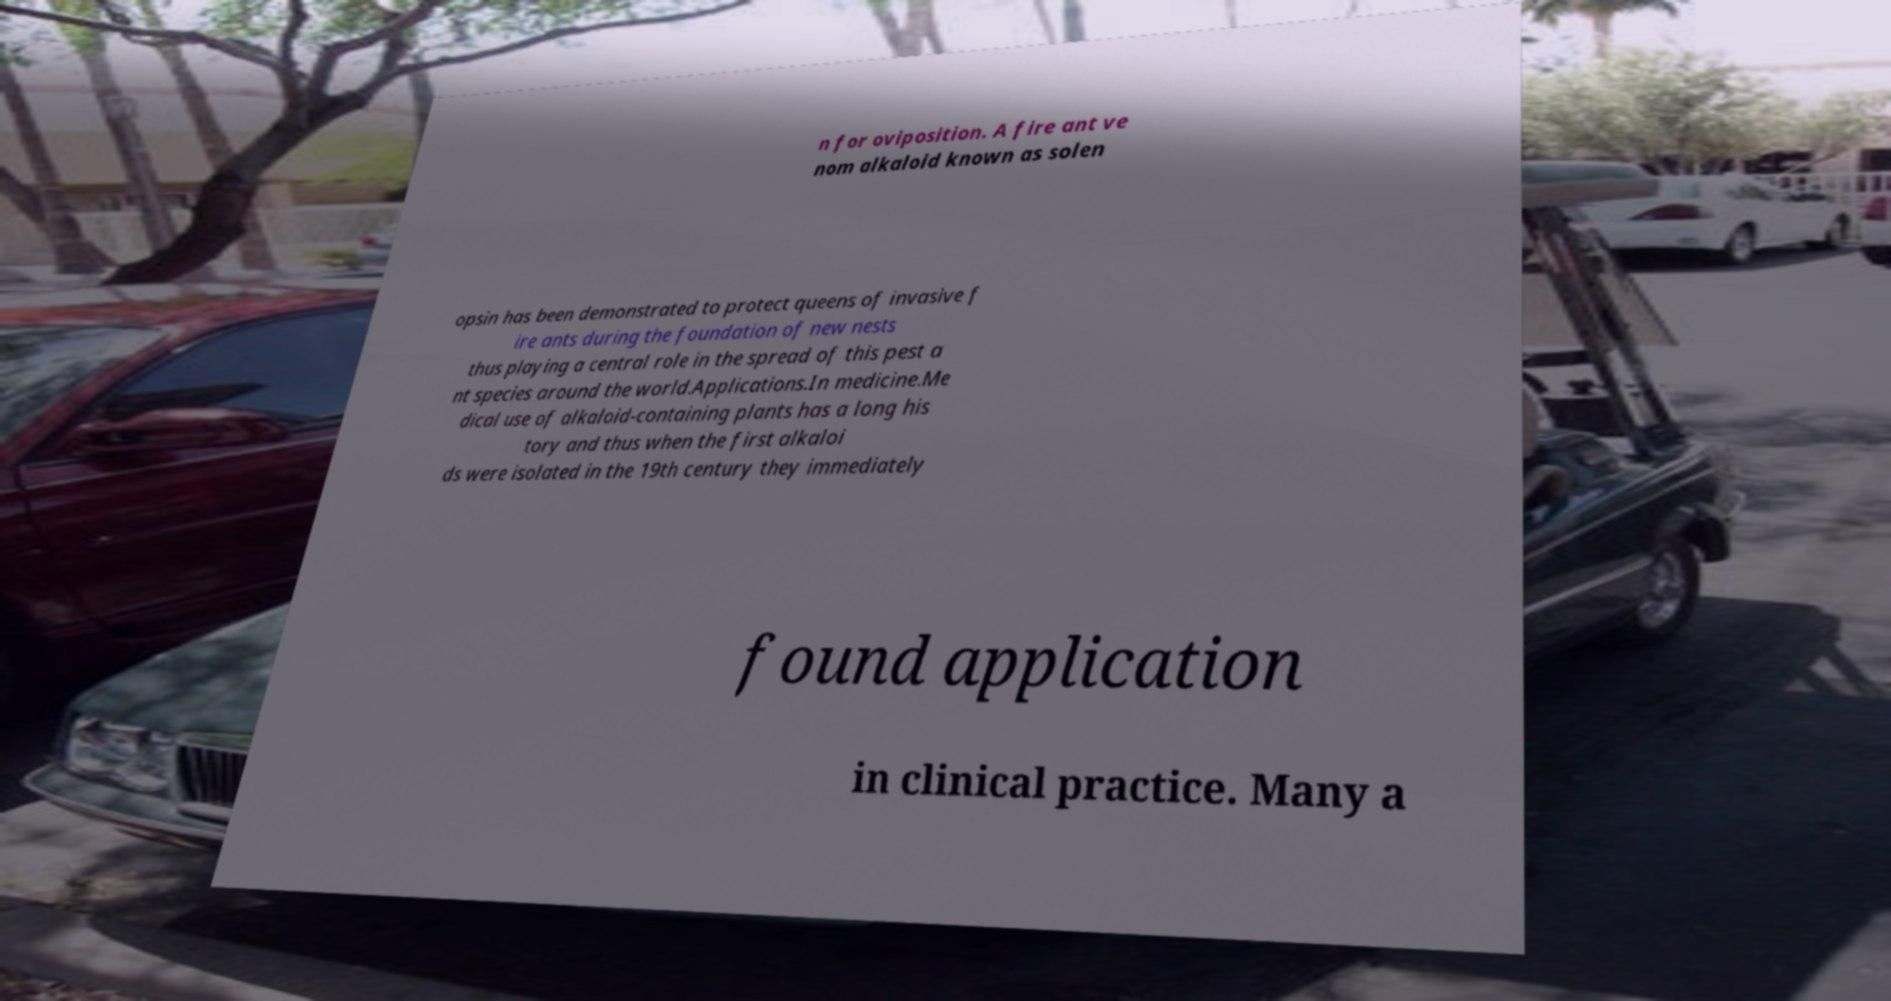Could you assist in decoding the text presented in this image and type it out clearly? n for oviposition. A fire ant ve nom alkaloid known as solen opsin has been demonstrated to protect queens of invasive f ire ants during the foundation of new nests thus playing a central role in the spread of this pest a nt species around the world.Applications.In medicine.Me dical use of alkaloid-containing plants has a long his tory and thus when the first alkaloi ds were isolated in the 19th century they immediately found application in clinical practice. Many a 